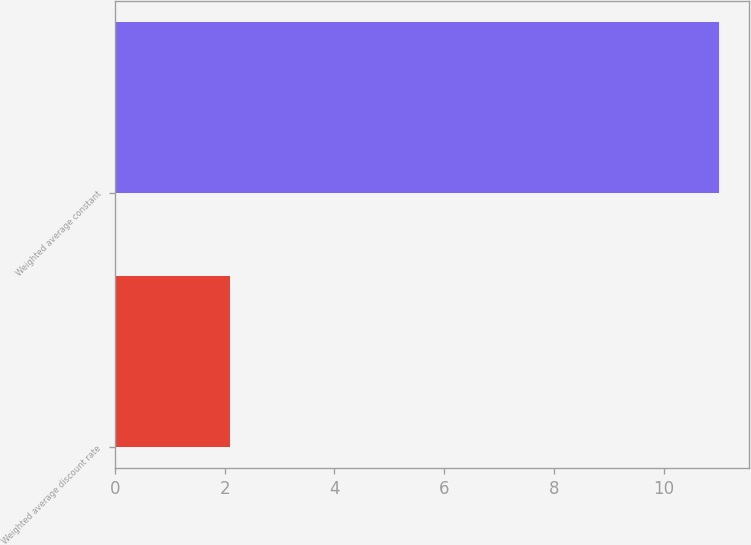Convert chart to OTSL. <chart><loc_0><loc_0><loc_500><loc_500><bar_chart><fcel>Weighted average discount rate<fcel>Weighted average constant<nl><fcel>2.1<fcel>11<nl></chart> 